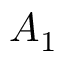<formula> <loc_0><loc_0><loc_500><loc_500>A _ { 1 }</formula> 